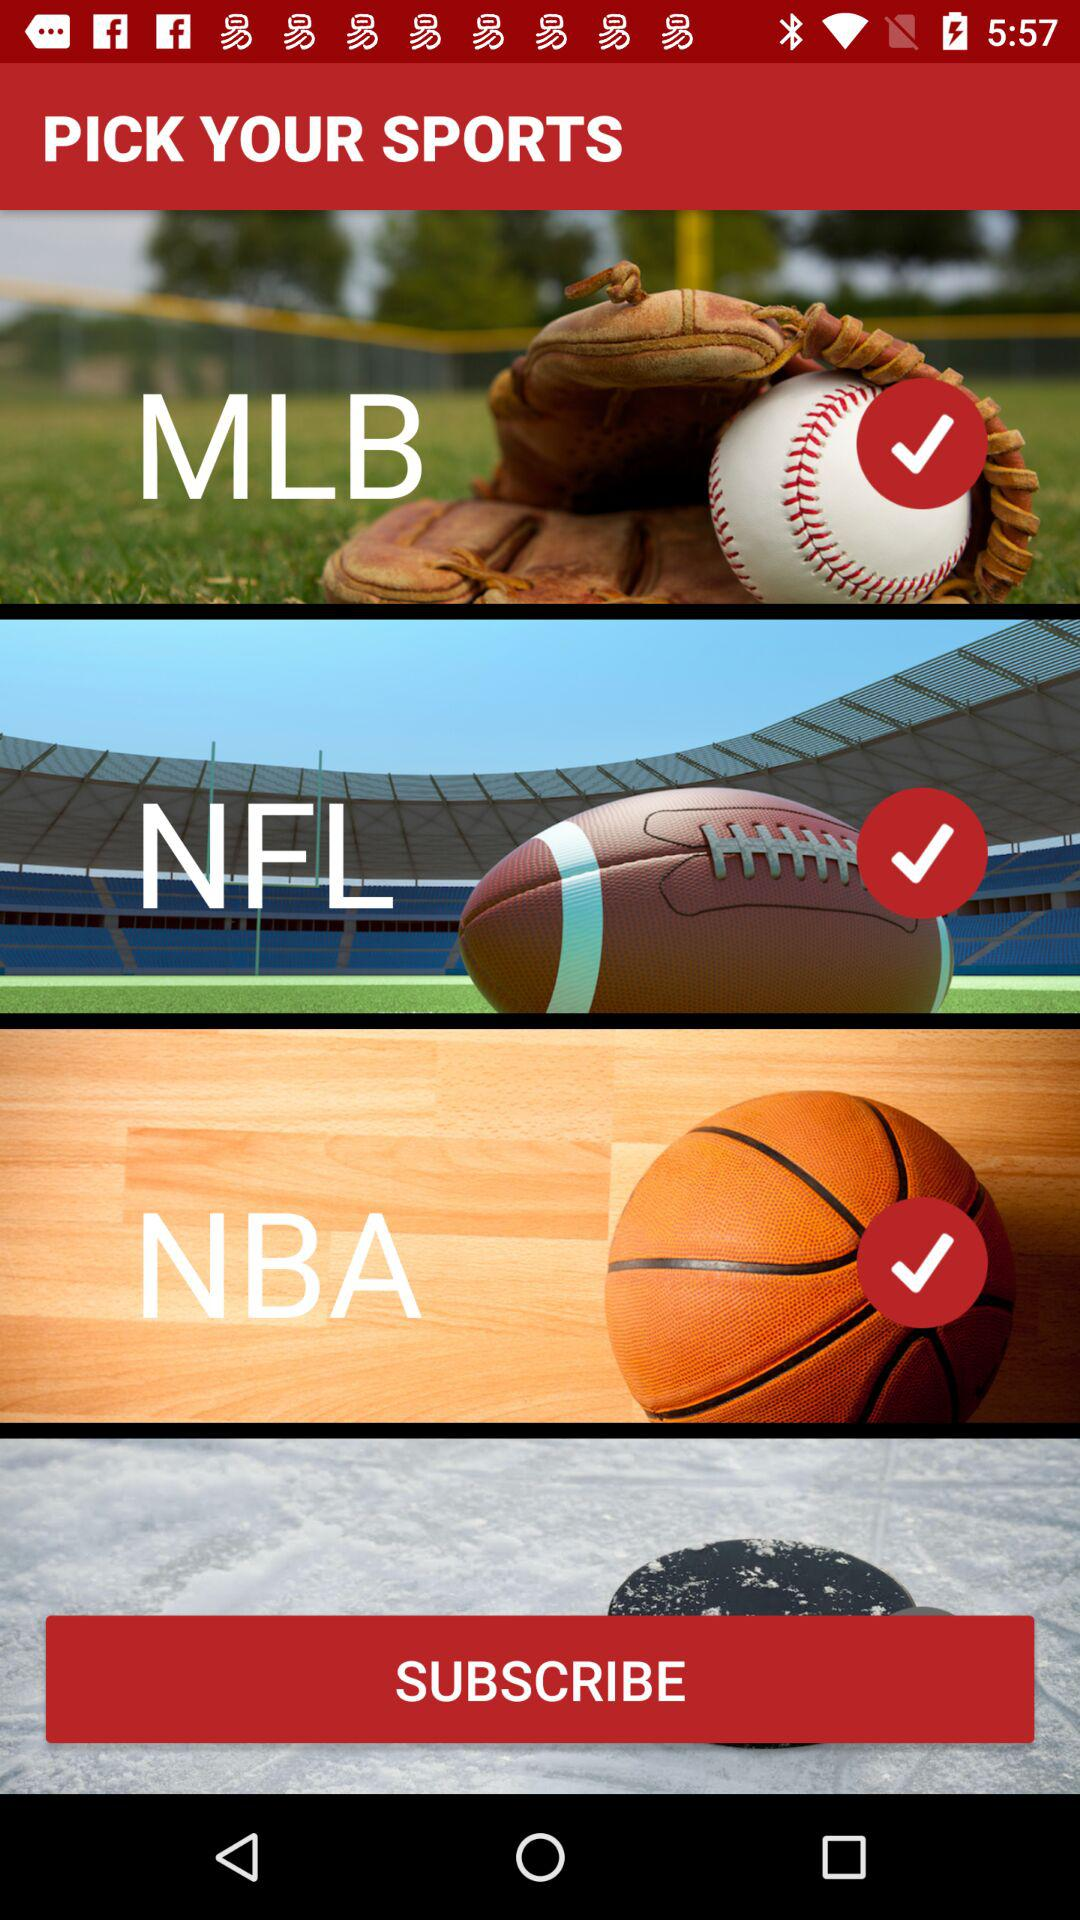How many sports can I follow?
Answer the question using a single word or phrase. 3 